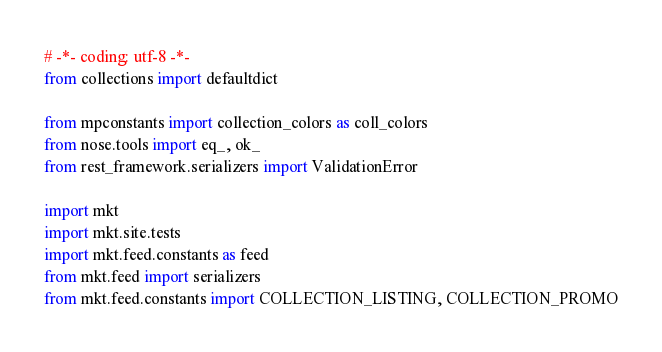<code> <loc_0><loc_0><loc_500><loc_500><_Python_># -*- coding: utf-8 -*-
from collections import defaultdict

from mpconstants import collection_colors as coll_colors
from nose.tools import eq_, ok_
from rest_framework.serializers import ValidationError

import mkt
import mkt.site.tests
import mkt.feed.constants as feed
from mkt.feed import serializers
from mkt.feed.constants import COLLECTION_LISTING, COLLECTION_PROMO</code> 